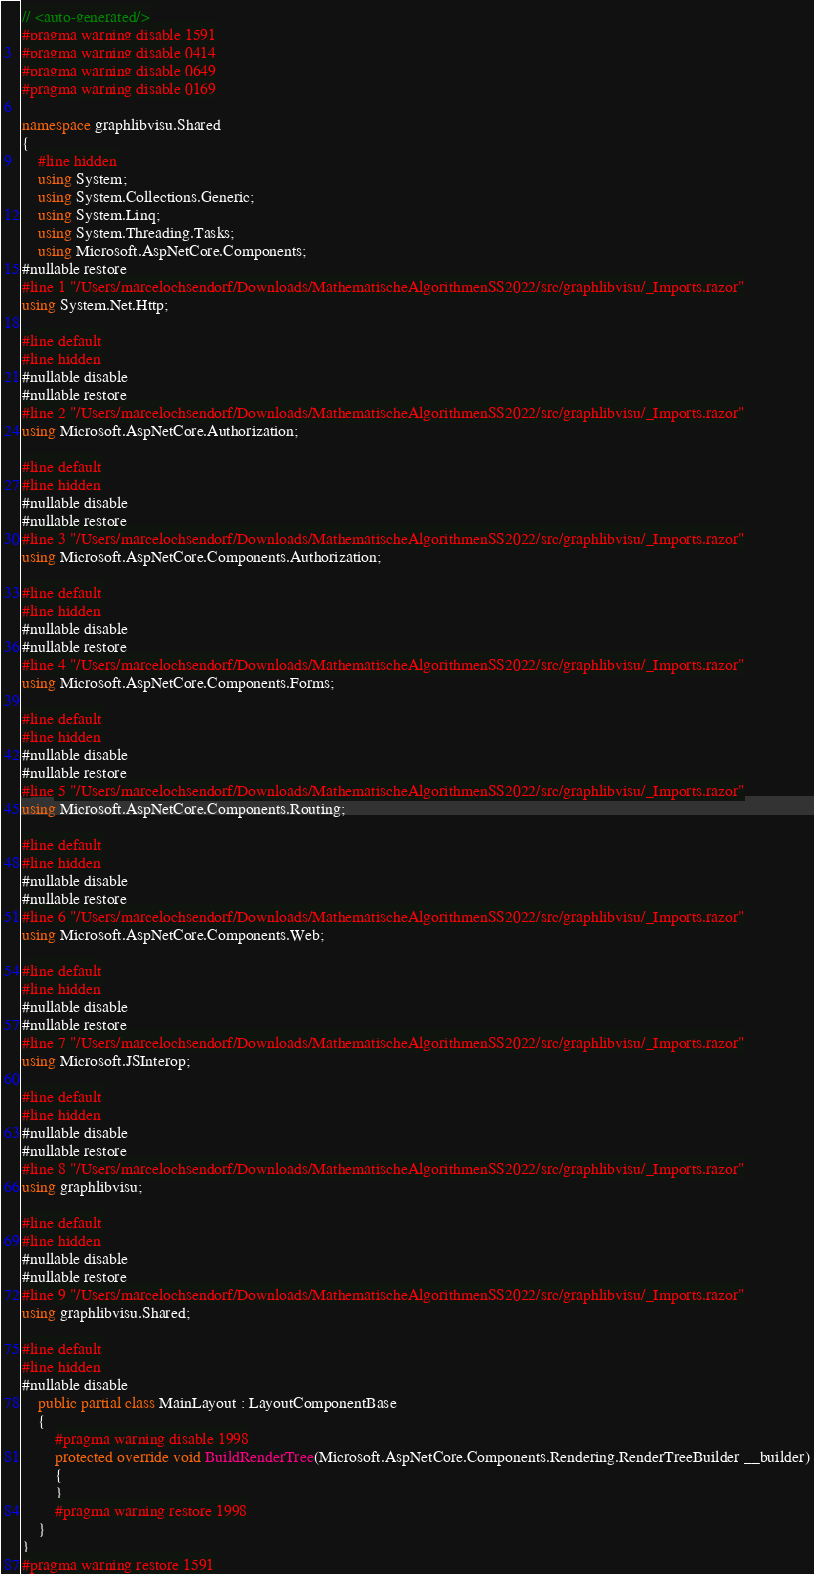<code> <loc_0><loc_0><loc_500><loc_500><_C#_>// <auto-generated/>
#pragma warning disable 1591
#pragma warning disable 0414
#pragma warning disable 0649
#pragma warning disable 0169

namespace graphlibvisu.Shared
{
    #line hidden
    using System;
    using System.Collections.Generic;
    using System.Linq;
    using System.Threading.Tasks;
    using Microsoft.AspNetCore.Components;
#nullable restore
#line 1 "/Users/marcelochsendorf/Downloads/MathematischeAlgorithmenSS2022/src/graphlibvisu/_Imports.razor"
using System.Net.Http;

#line default
#line hidden
#nullable disable
#nullable restore
#line 2 "/Users/marcelochsendorf/Downloads/MathematischeAlgorithmenSS2022/src/graphlibvisu/_Imports.razor"
using Microsoft.AspNetCore.Authorization;

#line default
#line hidden
#nullable disable
#nullable restore
#line 3 "/Users/marcelochsendorf/Downloads/MathematischeAlgorithmenSS2022/src/graphlibvisu/_Imports.razor"
using Microsoft.AspNetCore.Components.Authorization;

#line default
#line hidden
#nullable disable
#nullable restore
#line 4 "/Users/marcelochsendorf/Downloads/MathematischeAlgorithmenSS2022/src/graphlibvisu/_Imports.razor"
using Microsoft.AspNetCore.Components.Forms;

#line default
#line hidden
#nullable disable
#nullable restore
#line 5 "/Users/marcelochsendorf/Downloads/MathematischeAlgorithmenSS2022/src/graphlibvisu/_Imports.razor"
using Microsoft.AspNetCore.Components.Routing;

#line default
#line hidden
#nullable disable
#nullable restore
#line 6 "/Users/marcelochsendorf/Downloads/MathematischeAlgorithmenSS2022/src/graphlibvisu/_Imports.razor"
using Microsoft.AspNetCore.Components.Web;

#line default
#line hidden
#nullable disable
#nullable restore
#line 7 "/Users/marcelochsendorf/Downloads/MathematischeAlgorithmenSS2022/src/graphlibvisu/_Imports.razor"
using Microsoft.JSInterop;

#line default
#line hidden
#nullable disable
#nullable restore
#line 8 "/Users/marcelochsendorf/Downloads/MathematischeAlgorithmenSS2022/src/graphlibvisu/_Imports.razor"
using graphlibvisu;

#line default
#line hidden
#nullable disable
#nullable restore
#line 9 "/Users/marcelochsendorf/Downloads/MathematischeAlgorithmenSS2022/src/graphlibvisu/_Imports.razor"
using graphlibvisu.Shared;

#line default
#line hidden
#nullable disable
    public partial class MainLayout : LayoutComponentBase
    {
        #pragma warning disable 1998
        protected override void BuildRenderTree(Microsoft.AspNetCore.Components.Rendering.RenderTreeBuilder __builder)
        {
        }
        #pragma warning restore 1998
    }
}
#pragma warning restore 1591
</code> 